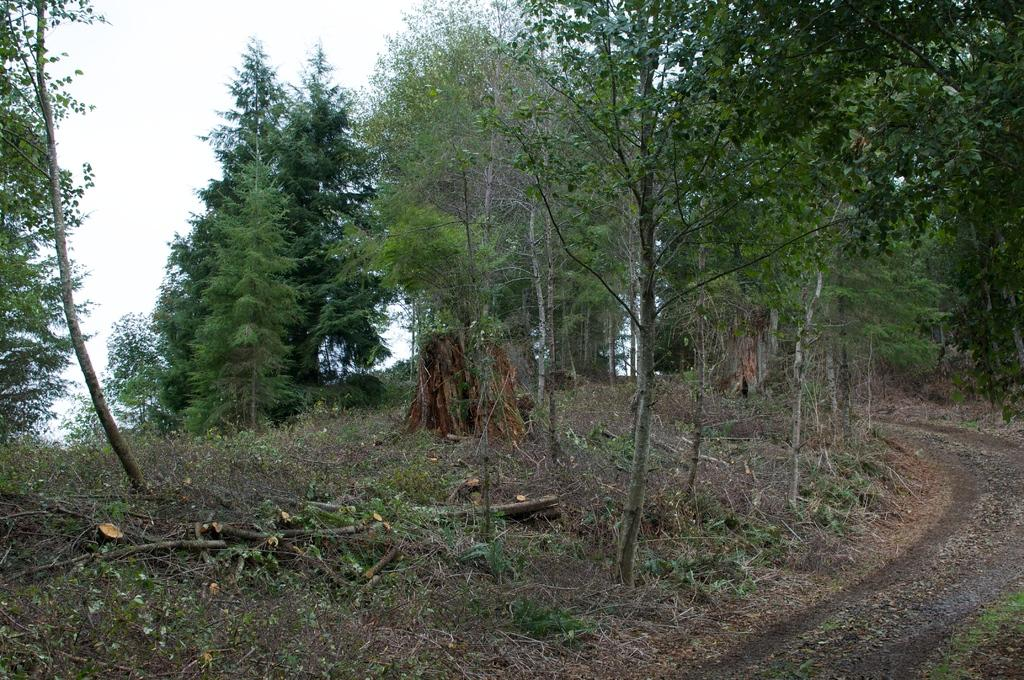What type of vegetation can be seen in the image? There are plants and trees in the image. What part of the natural environment is visible in the image? The sky is visible in the background of the image. What type of popcorn can be seen growing on the trees in the image? There is no popcorn present in the image; it is a natural scene with plants, trees, and the sky. 